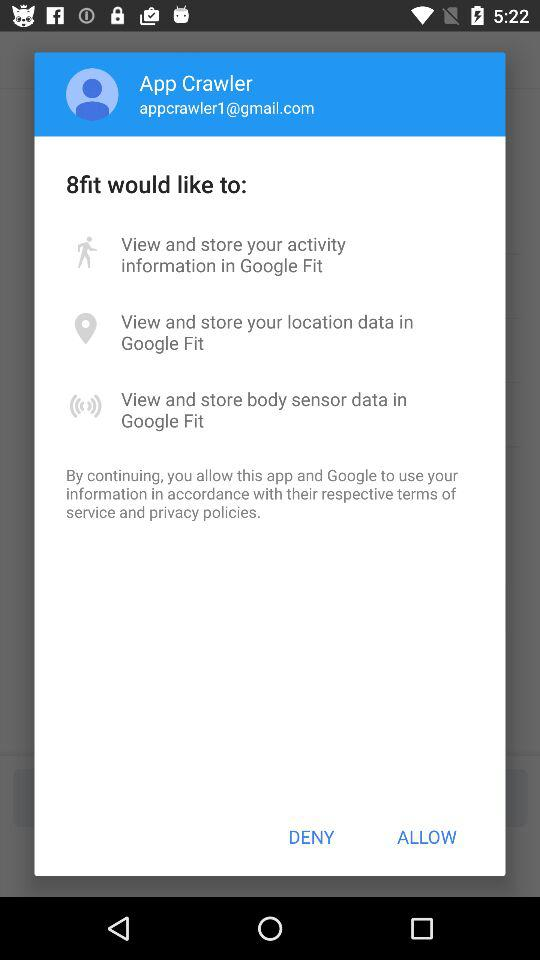What is the email address? The email address is appcrawler1@gmail.com. 